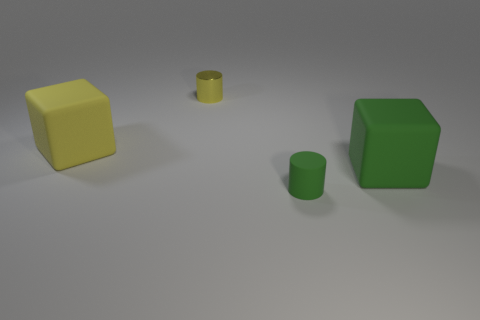Add 2 matte things. How many objects exist? 6 Subtract 1 yellow blocks. How many objects are left? 3 Subtract all yellow matte blocks. Subtract all big shiny balls. How many objects are left? 3 Add 1 small yellow things. How many small yellow things are left? 2 Add 3 yellow things. How many yellow things exist? 5 